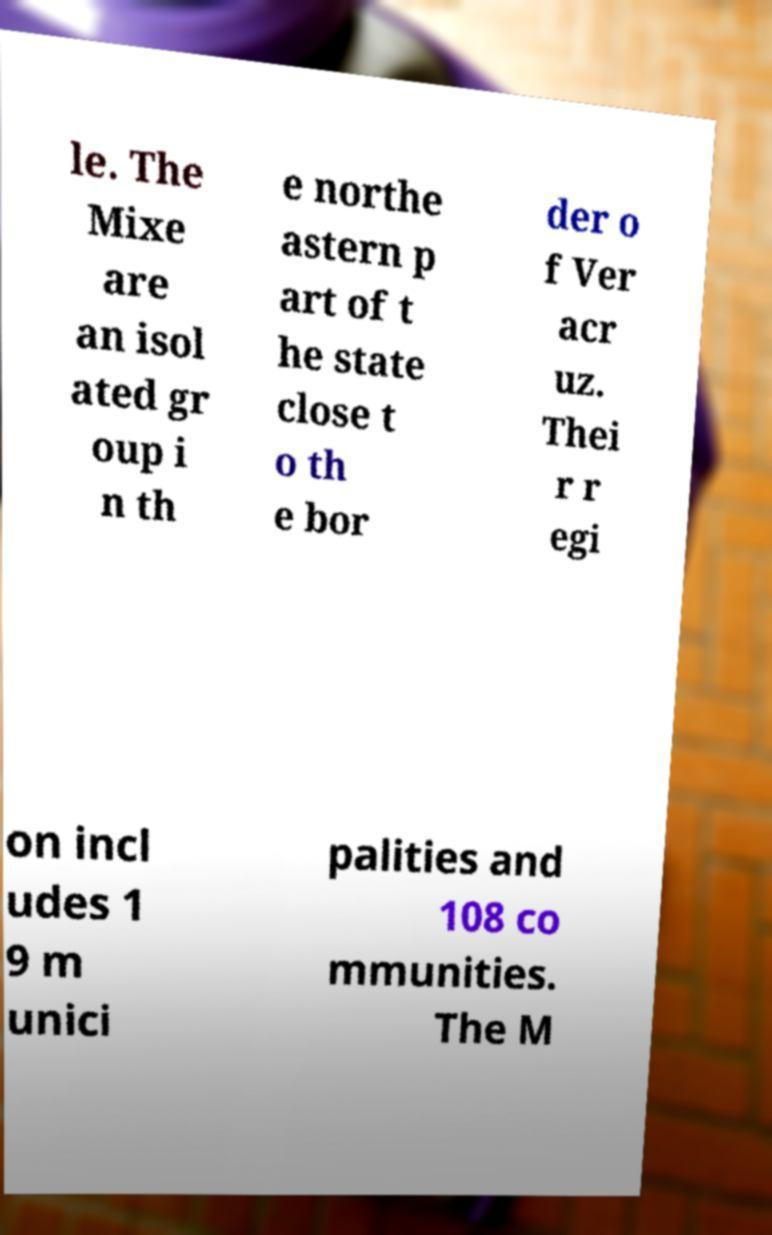Can you accurately transcribe the text from the provided image for me? le. The Mixe are an isol ated gr oup i n th e northe astern p art of t he state close t o th e bor der o f Ver acr uz. Thei r r egi on incl udes 1 9 m unici palities and 108 co mmunities. The M 